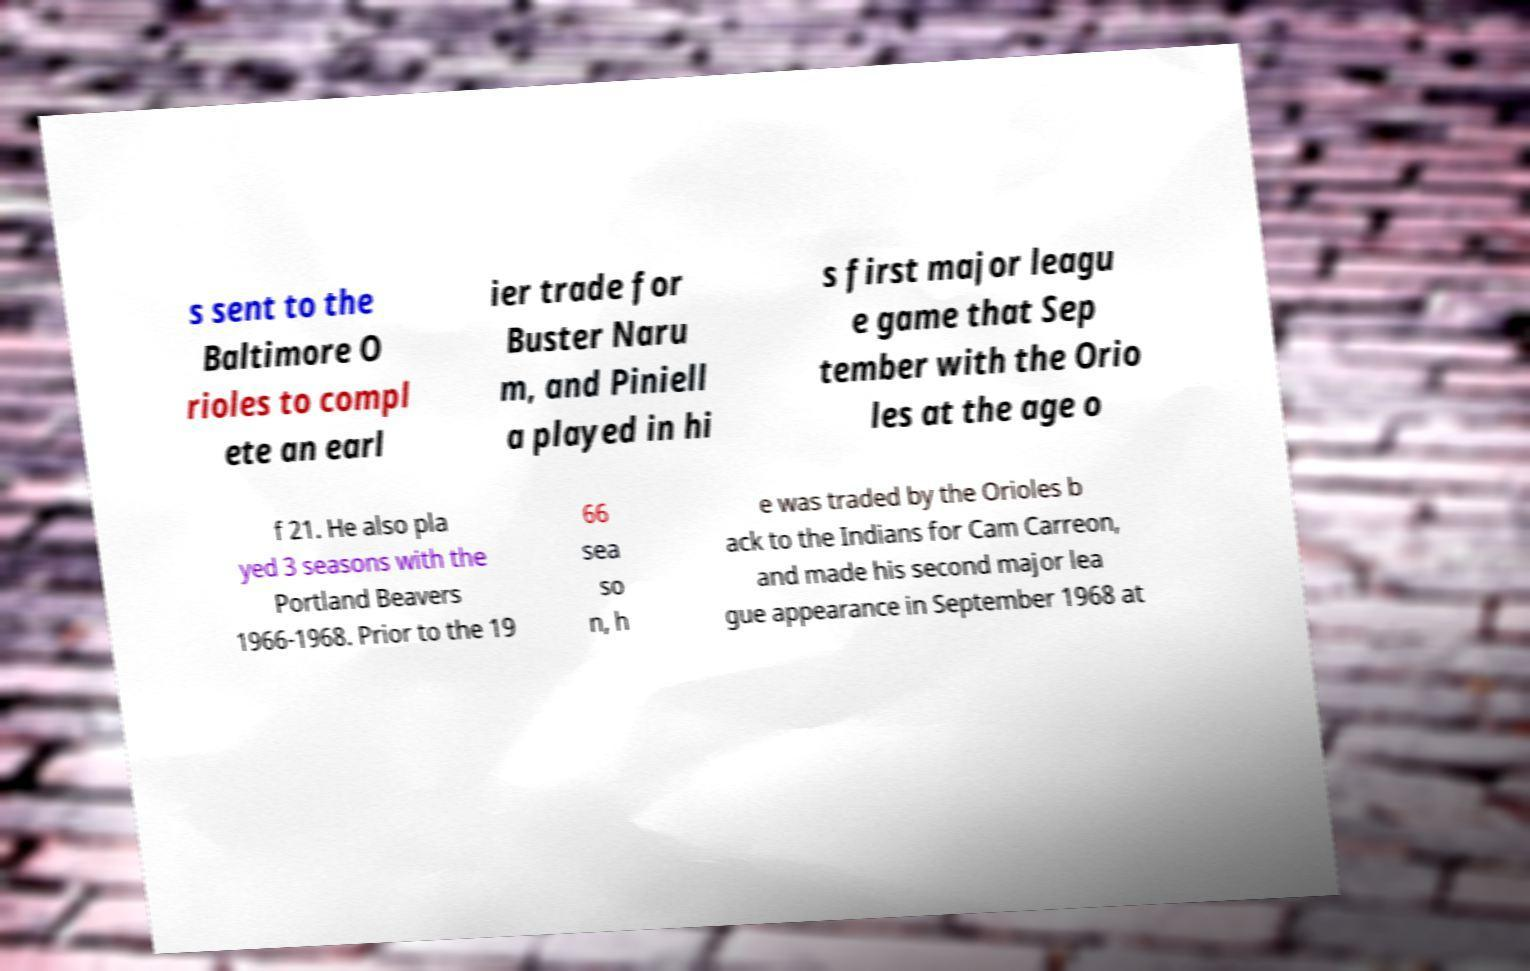Please read and relay the text visible in this image. What does it say? s sent to the Baltimore O rioles to compl ete an earl ier trade for Buster Naru m, and Piniell a played in hi s first major leagu e game that Sep tember with the Orio les at the age o f 21. He also pla yed 3 seasons with the Portland Beavers 1966-1968. Prior to the 19 66 sea so n, h e was traded by the Orioles b ack to the Indians for Cam Carreon, and made his second major lea gue appearance in September 1968 at 